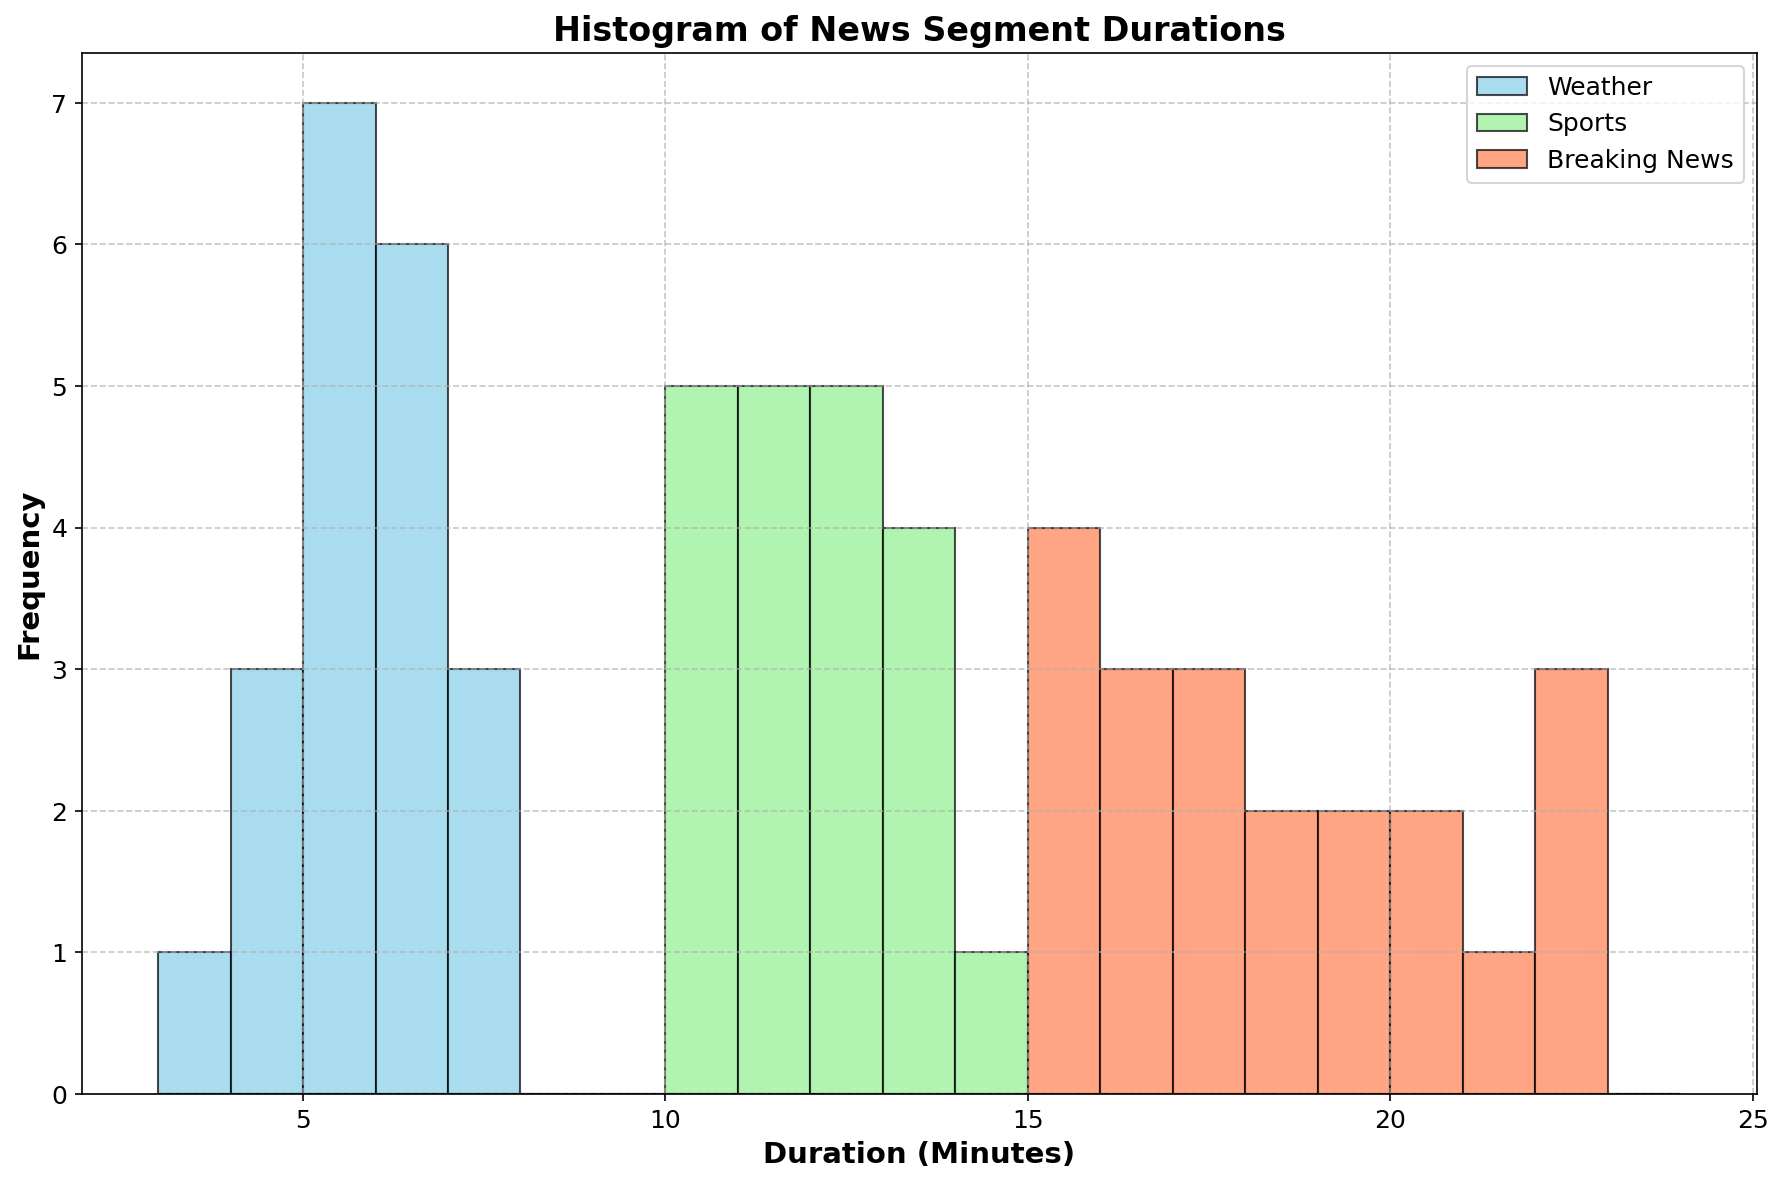What's the most frequent duration for Weather segments? By looking at the highest bar for the 'Weather' histogram (skyblue bars), we see that the most frequent duration is approximately 5 minutes.
Answer: 5 minutes How does the range of durations for Breaking News segments compare to that of Weather segments? The Breaking News (coral bars) durations range from 15 to 22 minutes while the Weather (skyblue bars) durations range from 3 to 7 minutes, indicating that Breaking News segments have a wider range.
Answer: Breaking News: 15-22 minutes, Weather: 3-7 minutes Which type of news segment has the widest variation in segment durations? By comparing the spans of the segment type histograms, Breaking News (coral bars) extends from 15 to 22 minutes, while Sports (light green) spans 10 to 14 minutes, and Weather (skyblue) from 3 to 7 minutes. Thus, Breaking News has the widest variation.
Answer: Breaking News How does the frequency of 10-minute segments in Sports compare to Weather segments? Observing the light green bars for Sports and skyblue bars for Weather, we see that 10-minute segments appear frequently in Sports but are non-existent in Weather segments.
Answer: Sports has 10-minute segments, Weather does not What is the average duration of Weather segments? Summing up all durations for Weather segments and dividing by their count: (5+6+4+5+7+5+6+3+5+4+6+6+5+7+6+4+5+6+7+5)/20 = 108/20 = 5.4 minutes.
Answer: 5.4 minutes How many more times does the 6-minute segment duration appear in Weather segments compared to Breaking News' 22-minute duration? The frequency of 6-minute segments in the Weather histogram is higher compared to the frequency of 22-minute segments in the Breaking News histogram. The exact counts are: Weather has six 6-minute durations, Breaking News has three 22-minute durations. Hence, 6/3 = 2 times more.
Answer: 2 times Which news segment type has the highest frequency and what is that frequency? By looking at the peak of each histogram, the 11-minute duration in the Sports histogram (light green bar) has the highest frequency, appearing 6 times.
Answer: Sports, Frequency: 6 What's the median duration for Sports segments? To find the median, sort the Sports segment durations and find the middle value(s): (10, 10, 10, 10, 11, 11, 11, 11, 11, 11, 12, 12, 12, 12, 12, 12, 13, 13, 13, 14). The middle values are the 10th and 11th, both 11 minutes. Thus, the median is 11 minutes.
Answer: 11 minutes 